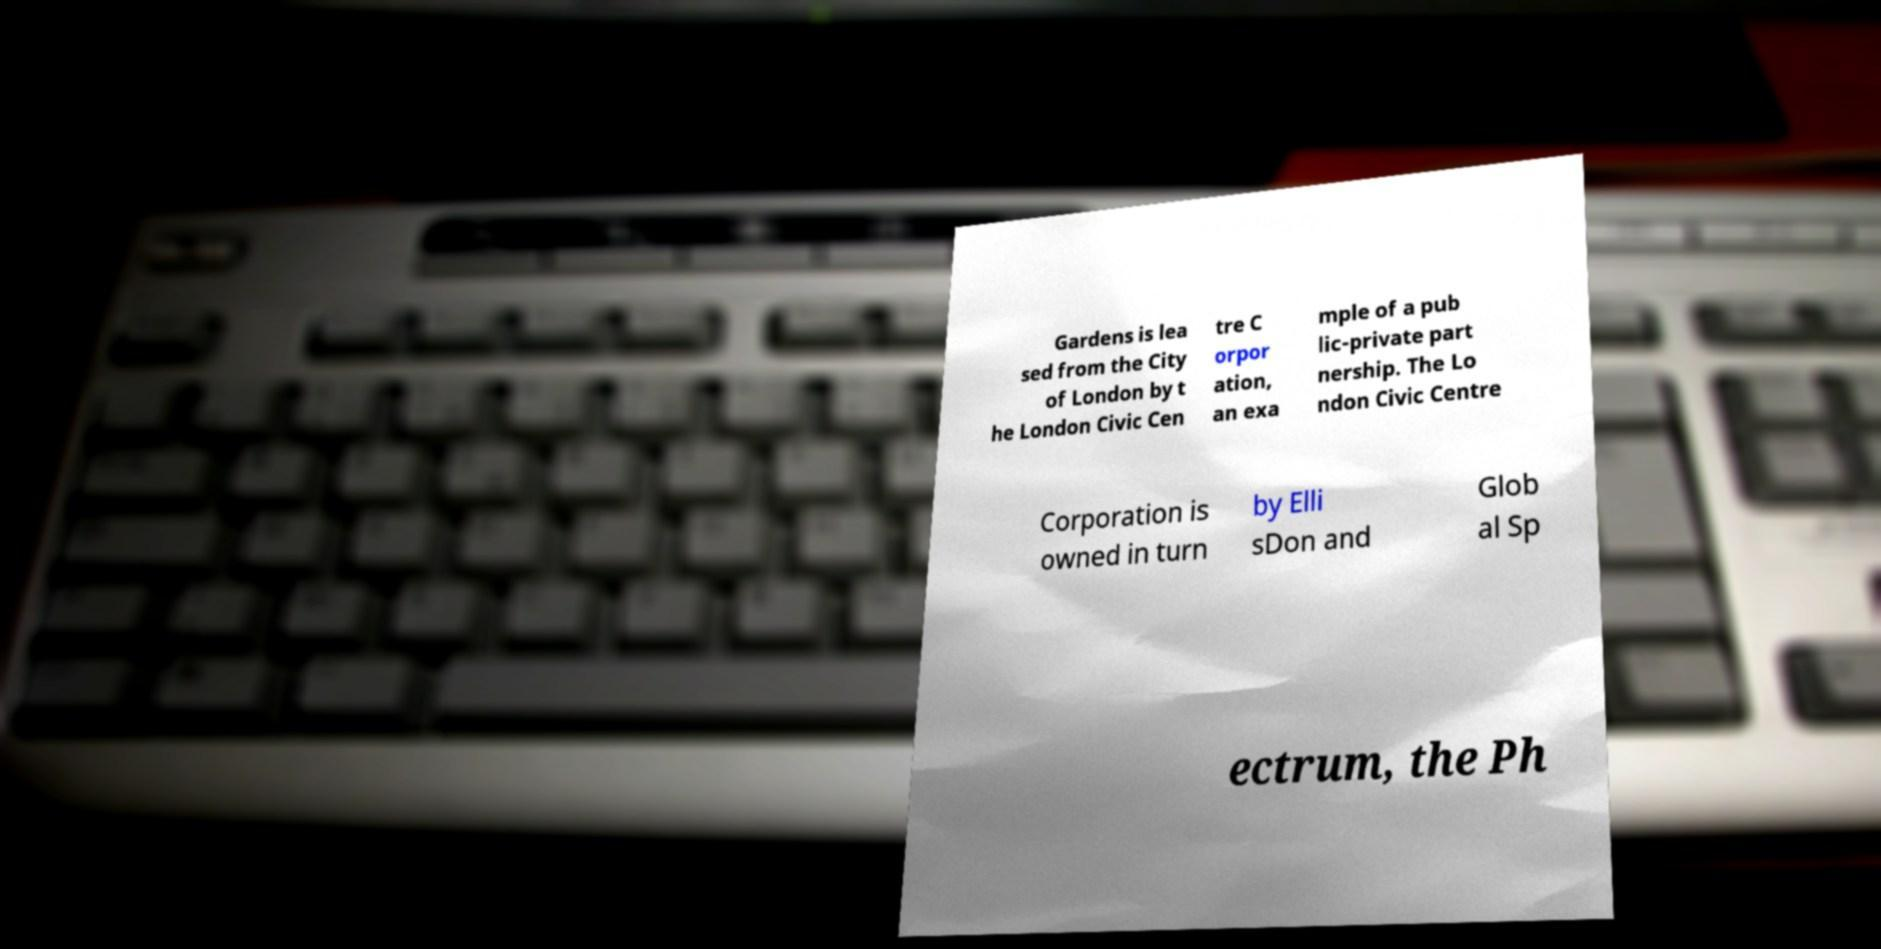Please read and relay the text visible in this image. What does it say? Gardens is lea sed from the City of London by t he London Civic Cen tre C orpor ation, an exa mple of a pub lic-private part nership. The Lo ndon Civic Centre Corporation is owned in turn by Elli sDon and Glob al Sp ectrum, the Ph 